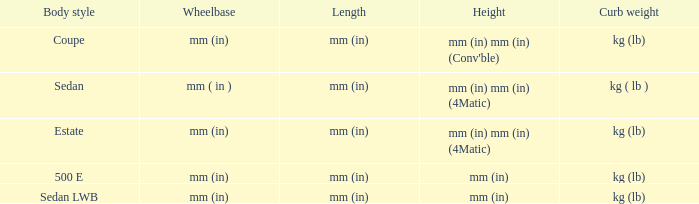What's the curb weight of the model with a wheelbase of mm (in) and height of mm (in) mm (in) (4Matic)? Kg ( lb ), kg (lb). 